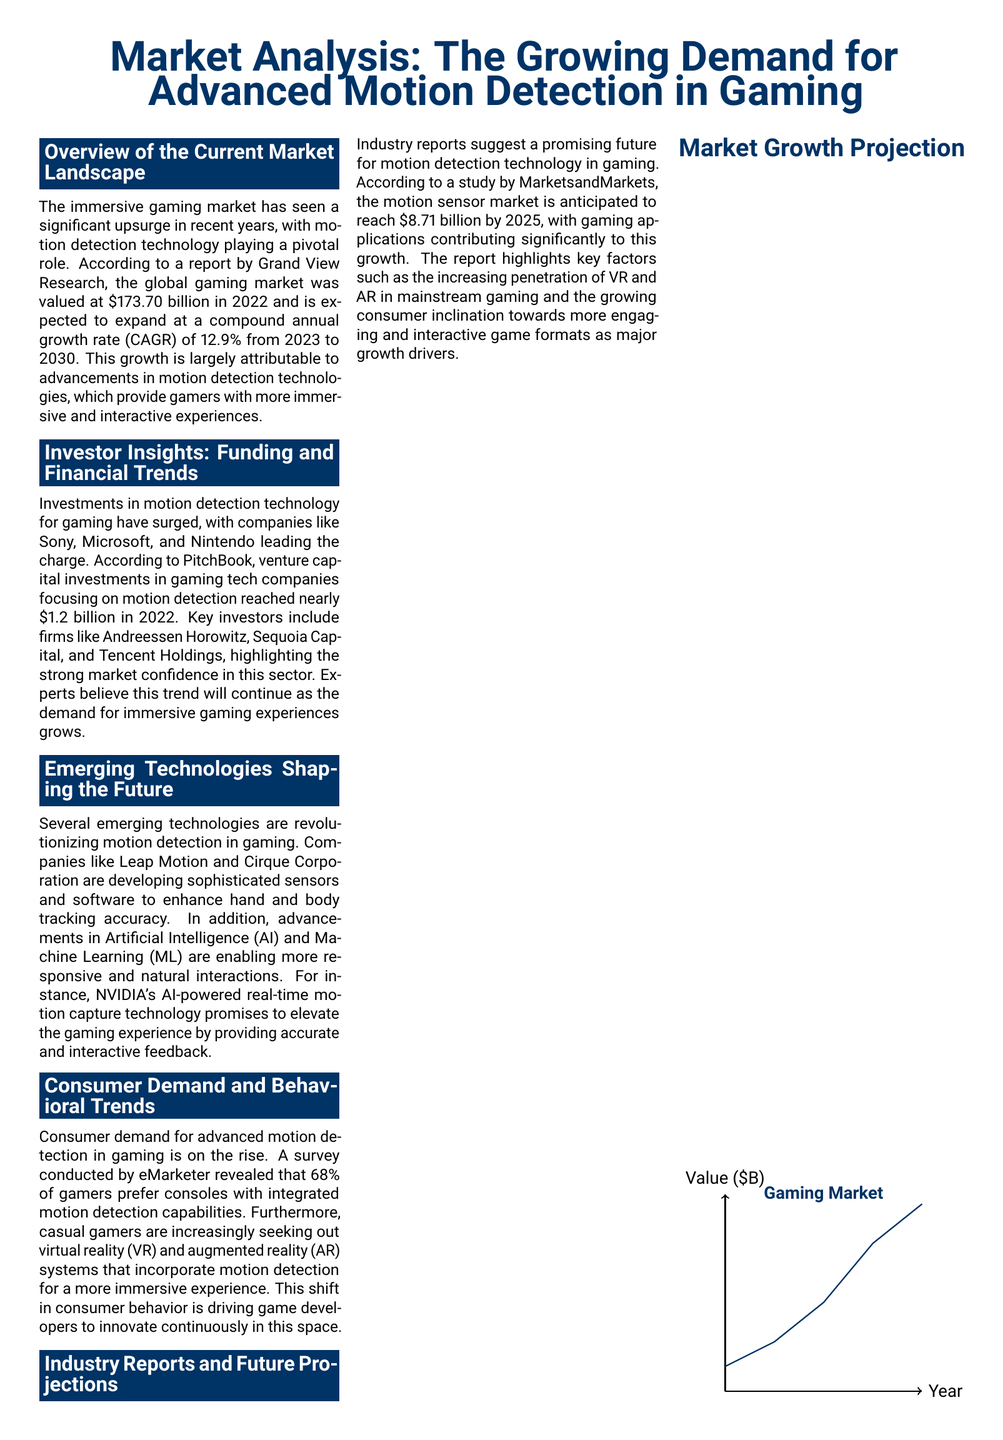What was the global gaming market value in 2022? The global gaming market was valued at $173.70 billion in 2022.
Answer: $173.70 billion What is the expected CAGR for the gaming market from 2023 to 2030? The document states that the expected CAGR from 2023 to 2030 is 12.9%.
Answer: 12.9% How much did venture capital investments in gaming tech companies reach in 2022? According to PitchBook, venture capital investments reached nearly $1.2 billion in 2022.
Answer: $1.2 billion What percentage of gamers prefer consoles with integrated motion detection? A survey revealed that 68% of gamers prefer consoles with integrated motion detection capabilities.
Answer: 68% What is the projected value of the motion sensor market by 2025? Industry reports suggest that the motion sensor market is anticipated to reach $8.71 billion by 2025.
Answer: $8.71 billion Which companies are leading in investments for motion detection technology? Companies like Sony, Microsoft, and Nintendo are leading in investments for motion detection technology.
Answer: Sony, Microsoft, and Nintendo What emerging technology is specifically mentioned for enhancing hand and body tracking? The document mentions Leap Motion as developing sophisticated sensors for enhancing hand and body tracking accuracy.
Answer: Leap Motion What are the key takeaways regarding gaming market growth? The key takeaways highlight important trends and projections regarding the gaming market's growth, such as a 12.9% CAGR and $1.2 billion in VC investment.
Answer: Market growth trends What is the primary focus of the document? The document focuses on the growing demand for advanced motion detection technology in gaming.
Answer: Advanced motion detection technology in gaming 